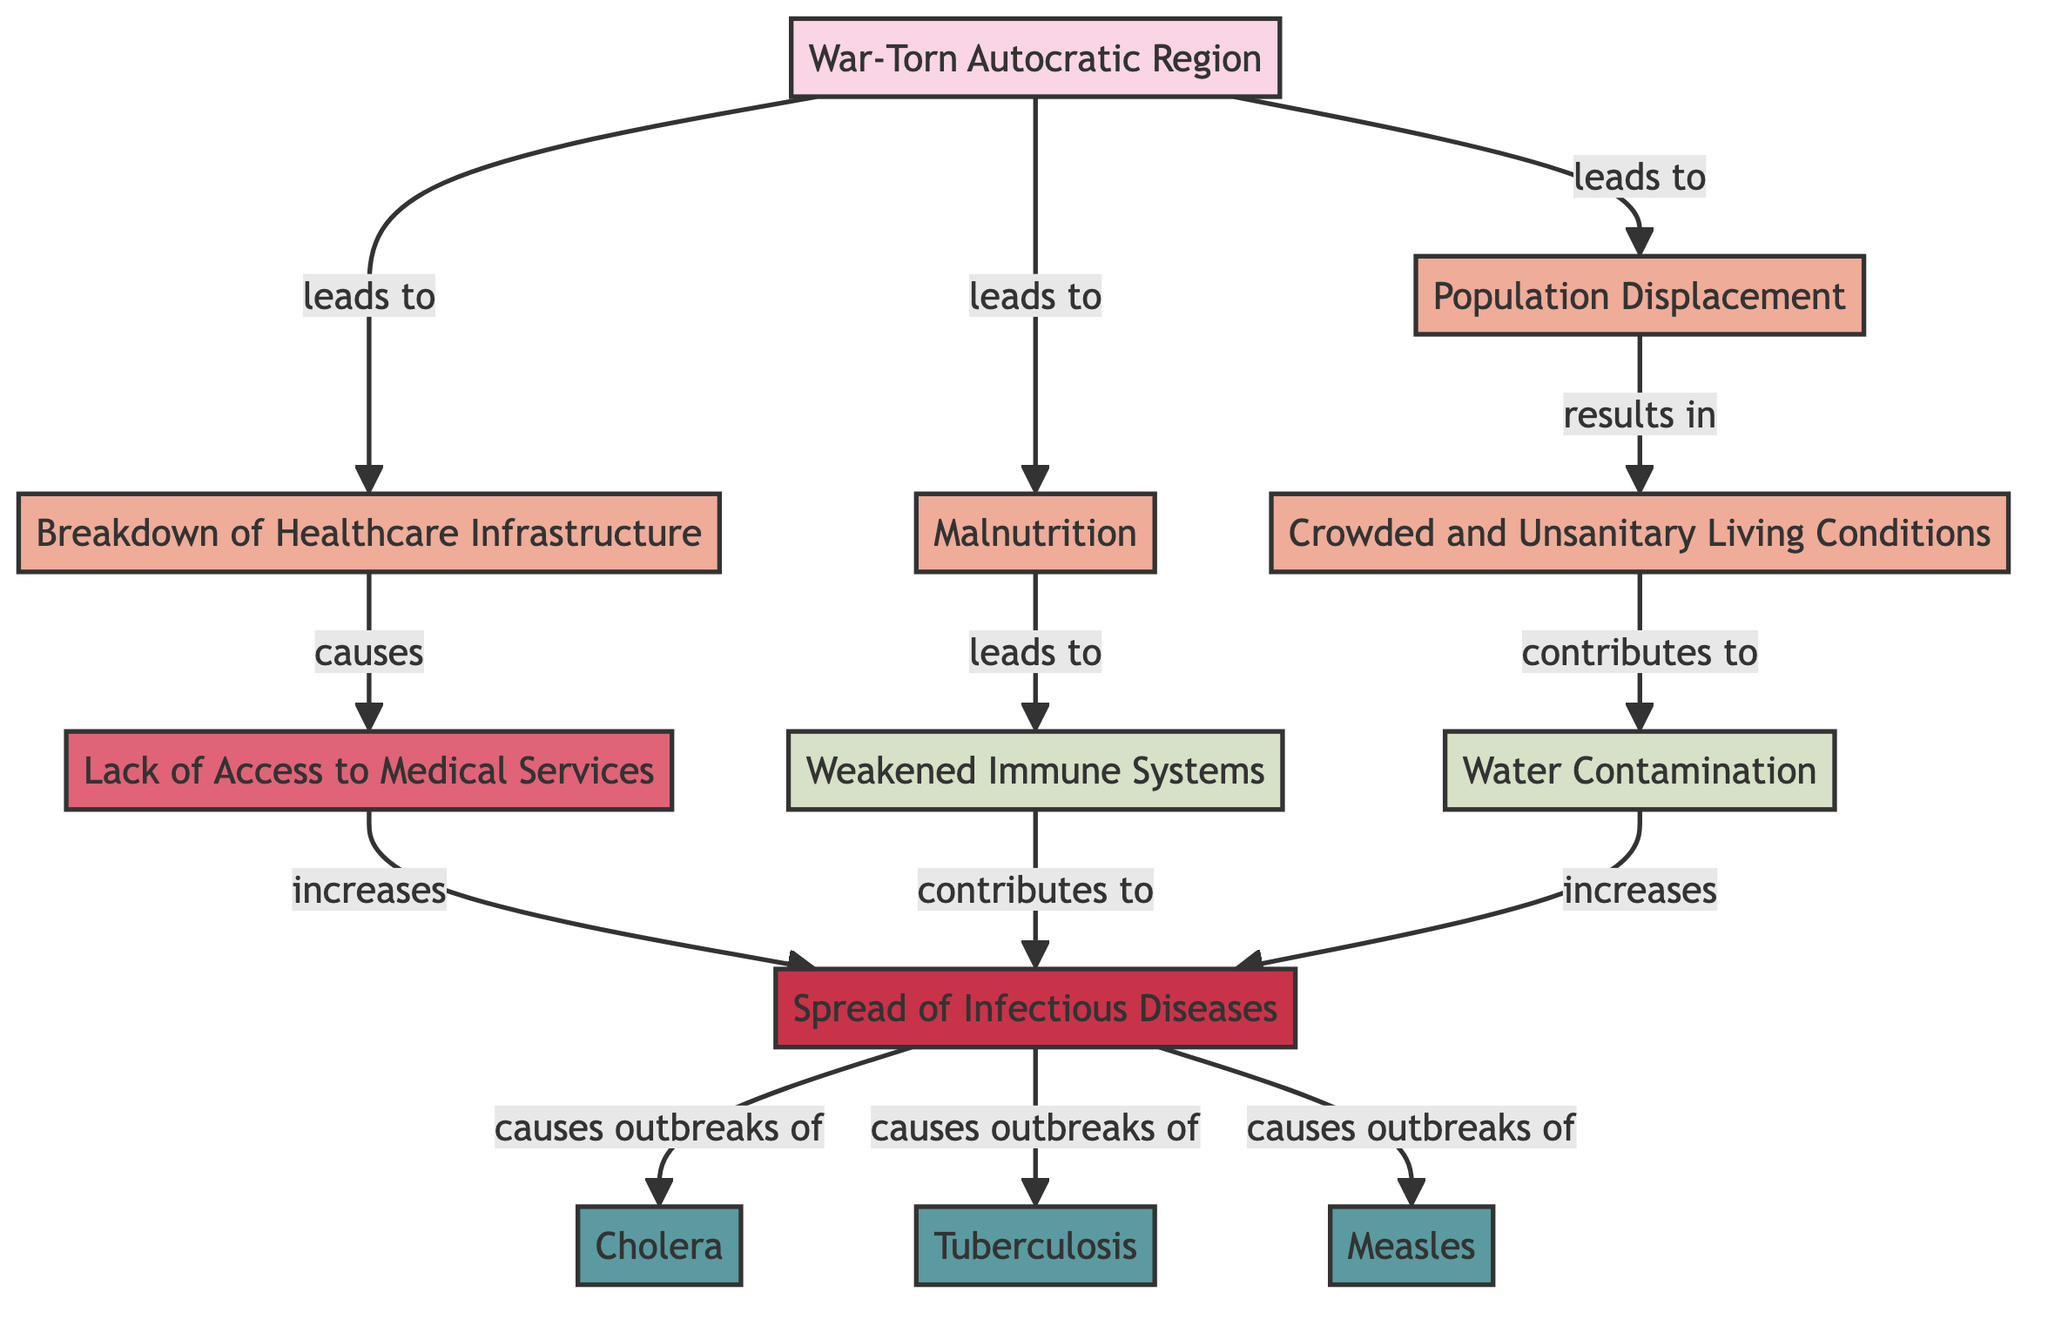What are the causes of the spread of infectious diseases in the diagram? The diagram indicates that the causes include the breakdown of healthcare infrastructure, malnutrition, population displacement, crowded and unsanitary living conditions, and lack of access to medical services.
Answer: Breakdown of Healthcare Infrastructure, Malnutrition, Population Displacement, Crowded and Unsanitary Living Conditions, Lack of Access to Medical Services How many diseases are identified in the diagram? The diagram shows three diseases, which are cholera, tuberculosis, and measles.
Answer: 3 What leads to the crowded and unsanitary living conditions? The crowded and unsanitary living conditions result from the population displacement shown in the diagram. The diagram specifically notes that population displacement results in these conditions.
Answer: Population Displacement Which disease is specifically linked to water contamination? Cholera is the disease that is specifically linked to water contamination according to the diagram. The relationship clearly shows that water contamination increases the spread of infectious diseases, including cholera.
Answer: Cholera What effect does a lack of access to medical services have? A lack of access to medical services increases the spread of infectious diseases as indicated by the flow from lack of access to medical services leading to an increase in disease spread.
Answer: Increases the spread of Infectious Diseases What contributes to weakened immune systems according to the diagram? The diagram indicates that malnutrition leads to weakened immune systems. Therefore, it is the result of malnutrition within the context of the presented causes and effects.
Answer: Malnutrition What is the primary outcome of the factors presented in the diagram? The primary outcome, as depicted in the diagram, is the spread of infectious diseases, which is an ultimate result of several causal factors mentioned.
Answer: Spread of Infectious Diseases How many causes are connected to the outcome of spread of infectious diseases? There are three main causes connected to the outcome of the spread of infectious diseases: weakened immune systems, lack of access to medical services, and water contamination. These are indicated as intermediary influences on the outcome.
Answer: 3 Which cause directly leads to the breakdown of healthcare infrastructure? The diagram indicates that a war-torn autocratic region directly leads to the breakdown of healthcare infrastructure, as it initiates a chain of causes related to healthcare collapse.
Answer: War-Torn Autocratic Region 